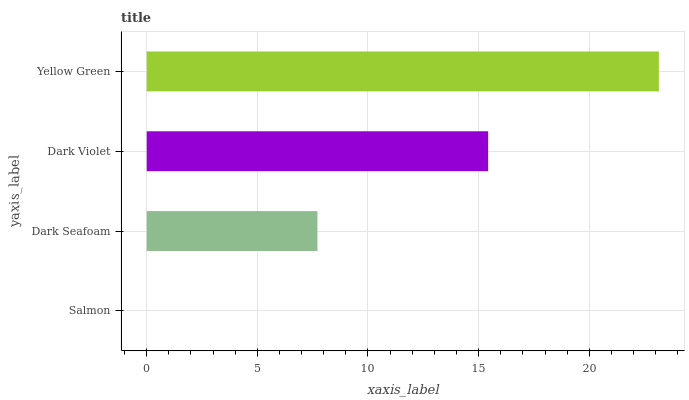Is Salmon the minimum?
Answer yes or no. Yes. Is Yellow Green the maximum?
Answer yes or no. Yes. Is Dark Seafoam the minimum?
Answer yes or no. No. Is Dark Seafoam the maximum?
Answer yes or no. No. Is Dark Seafoam greater than Salmon?
Answer yes or no. Yes. Is Salmon less than Dark Seafoam?
Answer yes or no. Yes. Is Salmon greater than Dark Seafoam?
Answer yes or no. No. Is Dark Seafoam less than Salmon?
Answer yes or no. No. Is Dark Violet the high median?
Answer yes or no. Yes. Is Dark Seafoam the low median?
Answer yes or no. Yes. Is Salmon the high median?
Answer yes or no. No. Is Yellow Green the low median?
Answer yes or no. No. 